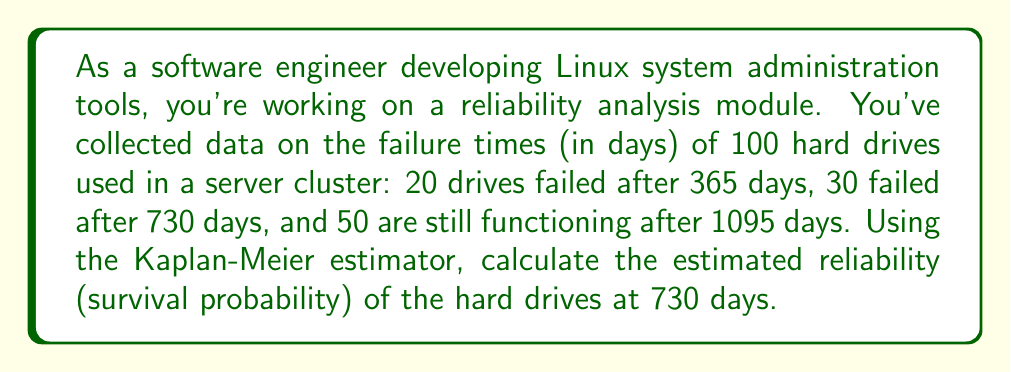Can you solve this math problem? To solve this problem, we'll use the Kaplan-Meier estimator, which is a non-parametric method for estimating the survival function. The steps are as follows:

1. Order the failure times:
   $t_1 = 365$ days, $t_2 = 730$ days

2. Calculate the number at risk and number of failures for each time point:
   At $t_1 = 365$ days: 
   $n_1 = 100$, $d_1 = 20$
   
   At $t_2 = 730$ days:
   $n_2 = 100 - 20 = 80$, $d_2 = 30$

3. Calculate the survival probability for each time point using the formula:
   $$S(t_i) = \prod_{j=1}^i \left(1 - \frac{d_j}{n_j}\right)$$

   For $t_1 = 365$ days:
   $$S(365) = 1 - \frac{20}{100} = 0.8$$

   For $t_2 = 730$ days:
   $$S(730) = S(365) \times \left(1 - \frac{30}{80}\right) = 0.8 \times 0.625 = 0.5$$

4. The estimated reliability at 730 days is $S(730) = 0.5$ or 50%.
Answer: 0.5 or 50% 